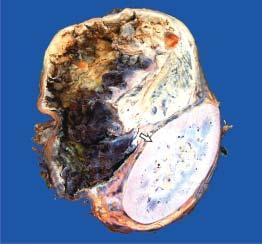does wide base show a large spherical tumour separate from the kidney?
Answer the question using a single word or phrase. No 